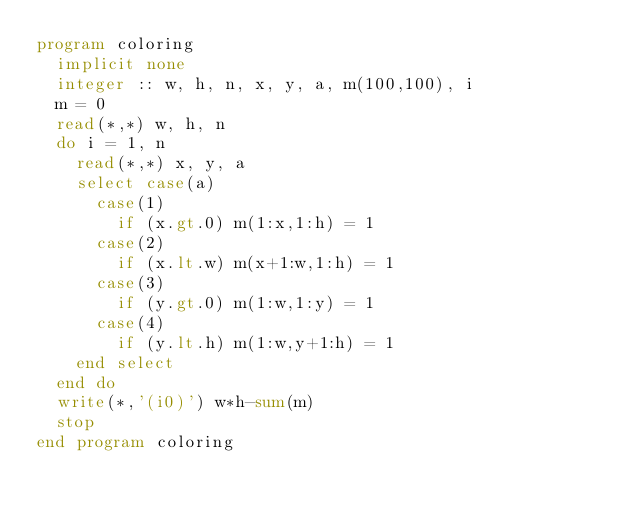<code> <loc_0><loc_0><loc_500><loc_500><_FORTRAN_>program coloring
  implicit none
  integer :: w, h, n, x, y, a, m(100,100), i
  m = 0
  read(*,*) w, h, n
  do i = 1, n
    read(*,*) x, y, a
    select case(a)
      case(1)
        if (x.gt.0) m(1:x,1:h) = 1
      case(2)
        if (x.lt.w) m(x+1:w,1:h) = 1
      case(3)
        if (y.gt.0) m(1:w,1:y) = 1
      case(4)
        if (y.lt.h) m(1:w,y+1:h) = 1
    end select
  end do
  write(*,'(i0)') w*h-sum(m)
  stop
end program coloring</code> 